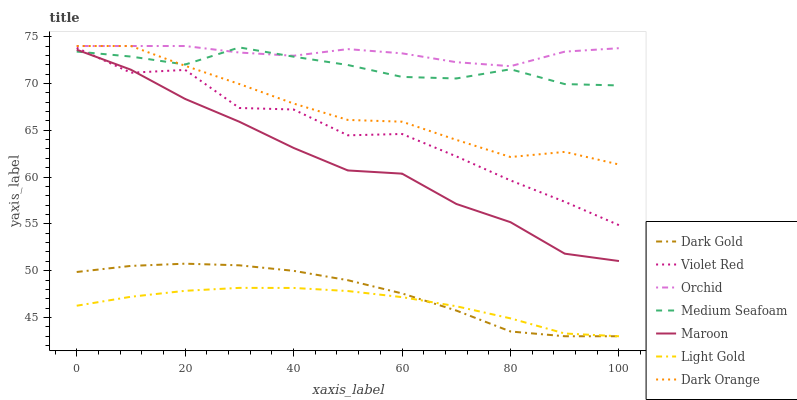Does Light Gold have the minimum area under the curve?
Answer yes or no. Yes. Does Orchid have the maximum area under the curve?
Answer yes or no. Yes. Does Violet Red have the minimum area under the curve?
Answer yes or no. No. Does Violet Red have the maximum area under the curve?
Answer yes or no. No. Is Light Gold the smoothest?
Answer yes or no. Yes. Is Violet Red the roughest?
Answer yes or no. Yes. Is Dark Gold the smoothest?
Answer yes or no. No. Is Dark Gold the roughest?
Answer yes or no. No. Does Dark Gold have the lowest value?
Answer yes or no. Yes. Does Violet Red have the lowest value?
Answer yes or no. No. Does Orchid have the highest value?
Answer yes or no. Yes. Does Violet Red have the highest value?
Answer yes or no. No. Is Dark Gold less than Orchid?
Answer yes or no. Yes. Is Dark Orange greater than Dark Gold?
Answer yes or no. Yes. Does Medium Seafoam intersect Maroon?
Answer yes or no. Yes. Is Medium Seafoam less than Maroon?
Answer yes or no. No. Is Medium Seafoam greater than Maroon?
Answer yes or no. No. Does Dark Gold intersect Orchid?
Answer yes or no. No. 